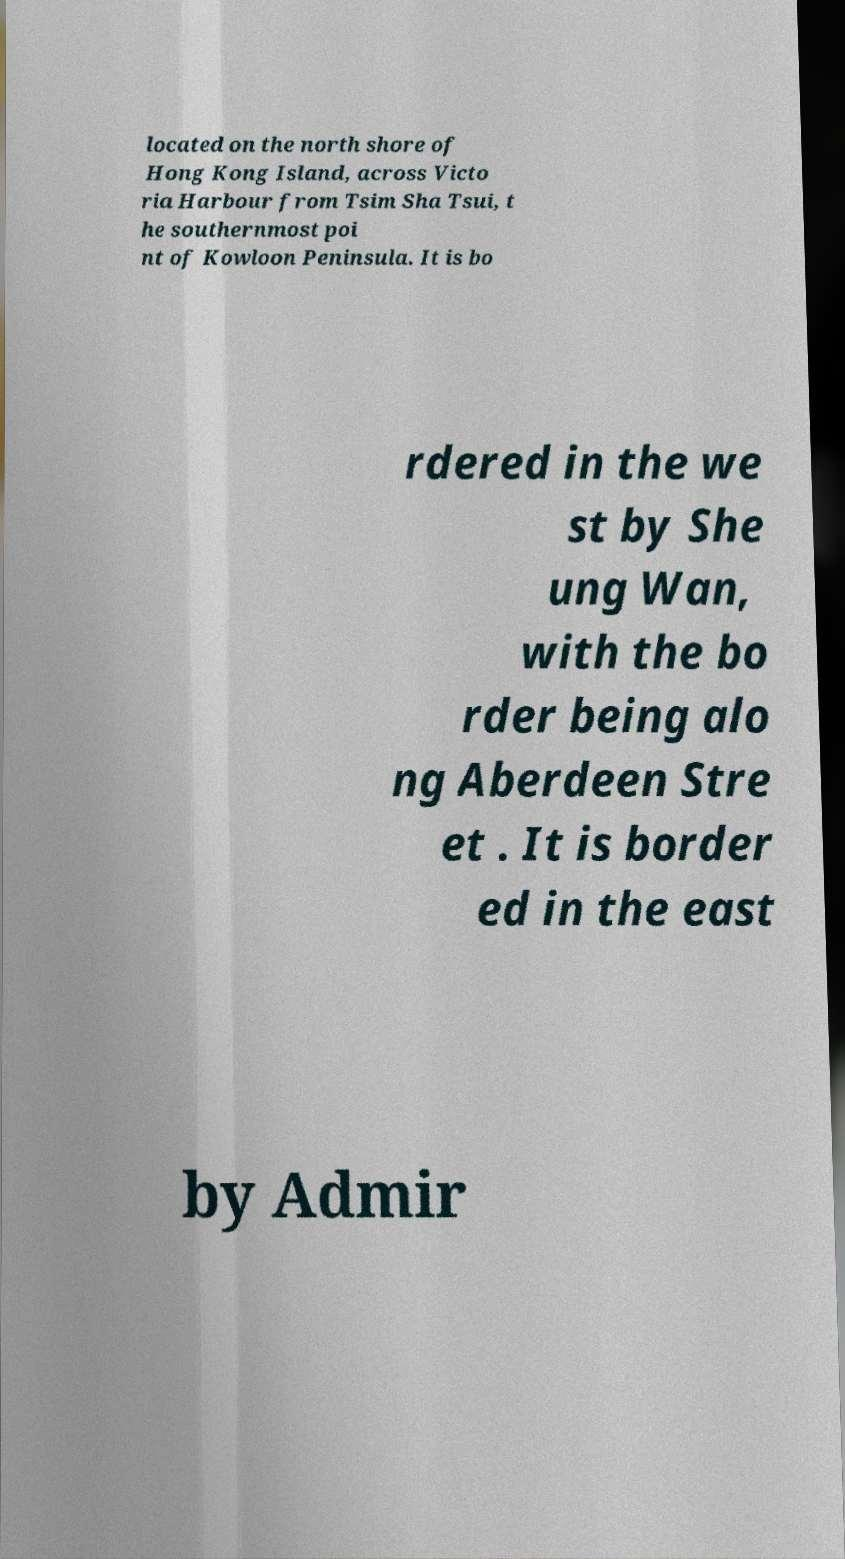Could you extract and type out the text from this image? located on the north shore of Hong Kong Island, across Victo ria Harbour from Tsim Sha Tsui, t he southernmost poi nt of Kowloon Peninsula. It is bo rdered in the we st by She ung Wan, with the bo rder being alo ng Aberdeen Stre et . It is border ed in the east by Admir 